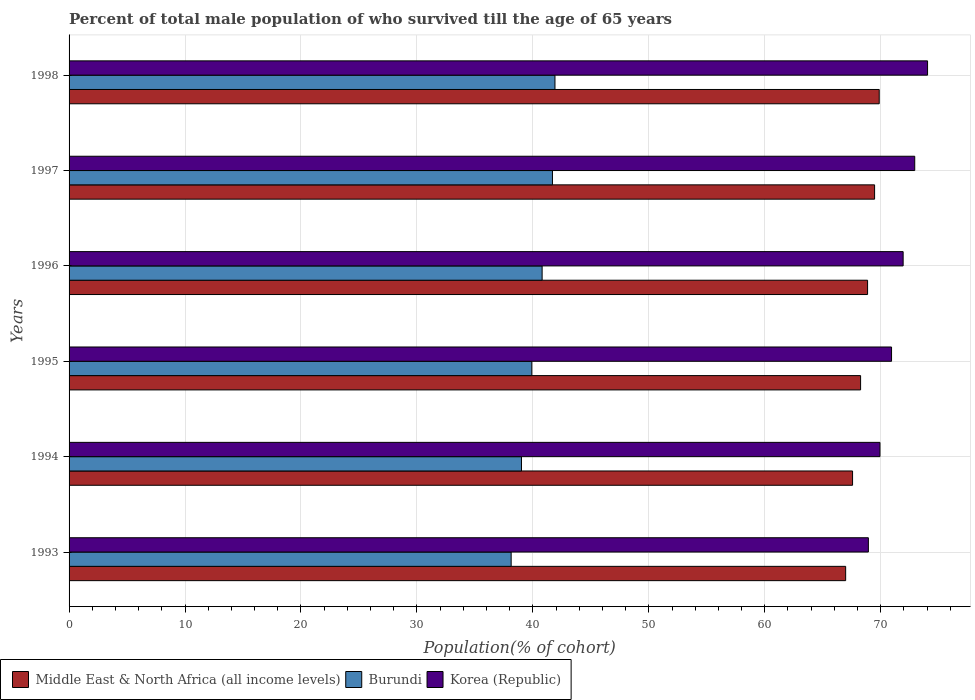How many groups of bars are there?
Offer a very short reply. 6. How many bars are there on the 1st tick from the top?
Ensure brevity in your answer.  3. What is the label of the 5th group of bars from the top?
Make the answer very short. 1994. In how many cases, is the number of bars for a given year not equal to the number of legend labels?
Make the answer very short. 0. What is the percentage of total male population who survived till the age of 65 years in Korea (Republic) in 1993?
Offer a very short reply. 68.94. Across all years, what is the maximum percentage of total male population who survived till the age of 65 years in Middle East & North Africa (all income levels)?
Provide a short and direct response. 69.87. Across all years, what is the minimum percentage of total male population who survived till the age of 65 years in Middle East & North Africa (all income levels)?
Give a very brief answer. 66.98. In which year was the percentage of total male population who survived till the age of 65 years in Middle East & North Africa (all income levels) maximum?
Your response must be concise. 1998. What is the total percentage of total male population who survived till the age of 65 years in Middle East & North Africa (all income levels) in the graph?
Your response must be concise. 411.03. What is the difference between the percentage of total male population who survived till the age of 65 years in Korea (Republic) in 1993 and that in 1998?
Offer a terse response. -5.11. What is the difference between the percentage of total male population who survived till the age of 65 years in Burundi in 1993 and the percentage of total male population who survived till the age of 65 years in Korea (Republic) in 1996?
Your response must be concise. -33.81. What is the average percentage of total male population who survived till the age of 65 years in Korea (Republic) per year?
Offer a terse response. 71.45. In the year 1996, what is the difference between the percentage of total male population who survived till the age of 65 years in Korea (Republic) and percentage of total male population who survived till the age of 65 years in Middle East & North Africa (all income levels)?
Your response must be concise. 3.07. In how many years, is the percentage of total male population who survived till the age of 65 years in Burundi greater than 48 %?
Make the answer very short. 0. What is the ratio of the percentage of total male population who survived till the age of 65 years in Middle East & North Africa (all income levels) in 1996 to that in 1997?
Provide a succinct answer. 0.99. What is the difference between the highest and the second highest percentage of total male population who survived till the age of 65 years in Burundi?
Your answer should be compact. 0.22. What is the difference between the highest and the lowest percentage of total male population who survived till the age of 65 years in Korea (Republic)?
Your answer should be compact. 5.11. In how many years, is the percentage of total male population who survived till the age of 65 years in Korea (Republic) greater than the average percentage of total male population who survived till the age of 65 years in Korea (Republic) taken over all years?
Provide a succinct answer. 3. What does the 1st bar from the top in 1996 represents?
Ensure brevity in your answer.  Korea (Republic). What does the 3rd bar from the bottom in 1998 represents?
Your answer should be compact. Korea (Republic). Is it the case that in every year, the sum of the percentage of total male population who survived till the age of 65 years in Korea (Republic) and percentage of total male population who survived till the age of 65 years in Middle East & North Africa (all income levels) is greater than the percentage of total male population who survived till the age of 65 years in Burundi?
Your answer should be very brief. Yes. How many bars are there?
Your answer should be very brief. 18. Are all the bars in the graph horizontal?
Your answer should be very brief. Yes. How many years are there in the graph?
Provide a succinct answer. 6. Does the graph contain any zero values?
Your answer should be very brief. No. What is the title of the graph?
Offer a very short reply. Percent of total male population of who survived till the age of 65 years. Does "Korea (Democratic)" appear as one of the legend labels in the graph?
Your answer should be compact. No. What is the label or title of the X-axis?
Your response must be concise. Population(% of cohort). What is the label or title of the Y-axis?
Provide a short and direct response. Years. What is the Population(% of cohort) of Middle East & North Africa (all income levels) in 1993?
Make the answer very short. 66.98. What is the Population(% of cohort) of Burundi in 1993?
Your answer should be very brief. 38.13. What is the Population(% of cohort) of Korea (Republic) in 1993?
Ensure brevity in your answer.  68.94. What is the Population(% of cohort) in Middle East & North Africa (all income levels) in 1994?
Your answer should be very brief. 67.57. What is the Population(% of cohort) in Burundi in 1994?
Offer a terse response. 39.02. What is the Population(% of cohort) of Korea (Republic) in 1994?
Ensure brevity in your answer.  69.94. What is the Population(% of cohort) of Middle East & North Africa (all income levels) in 1995?
Ensure brevity in your answer.  68.27. What is the Population(% of cohort) in Burundi in 1995?
Give a very brief answer. 39.91. What is the Population(% of cohort) in Korea (Republic) in 1995?
Ensure brevity in your answer.  70.94. What is the Population(% of cohort) of Middle East & North Africa (all income levels) in 1996?
Give a very brief answer. 68.87. What is the Population(% of cohort) of Burundi in 1996?
Your answer should be very brief. 40.8. What is the Population(% of cohort) in Korea (Republic) in 1996?
Offer a terse response. 71.94. What is the Population(% of cohort) of Middle East & North Africa (all income levels) in 1997?
Provide a succinct answer. 69.47. What is the Population(% of cohort) in Burundi in 1997?
Ensure brevity in your answer.  41.69. What is the Population(% of cohort) of Korea (Republic) in 1997?
Provide a succinct answer. 72.94. What is the Population(% of cohort) in Middle East & North Africa (all income levels) in 1998?
Provide a succinct answer. 69.87. What is the Population(% of cohort) in Burundi in 1998?
Keep it short and to the point. 41.91. What is the Population(% of cohort) of Korea (Republic) in 1998?
Keep it short and to the point. 74.04. Across all years, what is the maximum Population(% of cohort) in Middle East & North Africa (all income levels)?
Give a very brief answer. 69.87. Across all years, what is the maximum Population(% of cohort) of Burundi?
Your answer should be compact. 41.91. Across all years, what is the maximum Population(% of cohort) of Korea (Republic)?
Ensure brevity in your answer.  74.04. Across all years, what is the minimum Population(% of cohort) of Middle East & North Africa (all income levels)?
Provide a succinct answer. 66.98. Across all years, what is the minimum Population(% of cohort) in Burundi?
Provide a short and direct response. 38.13. Across all years, what is the minimum Population(% of cohort) of Korea (Republic)?
Keep it short and to the point. 68.94. What is the total Population(% of cohort) in Middle East & North Africa (all income levels) in the graph?
Your answer should be very brief. 411.03. What is the total Population(% of cohort) in Burundi in the graph?
Ensure brevity in your answer.  241.45. What is the total Population(% of cohort) in Korea (Republic) in the graph?
Make the answer very short. 428.72. What is the difference between the Population(% of cohort) in Middle East & North Africa (all income levels) in 1993 and that in 1994?
Your answer should be compact. -0.6. What is the difference between the Population(% of cohort) of Burundi in 1993 and that in 1994?
Make the answer very short. -0.89. What is the difference between the Population(% of cohort) in Korea (Republic) in 1993 and that in 1994?
Provide a succinct answer. -1. What is the difference between the Population(% of cohort) in Middle East & North Africa (all income levels) in 1993 and that in 1995?
Offer a terse response. -1.29. What is the difference between the Population(% of cohort) in Burundi in 1993 and that in 1995?
Make the answer very short. -1.78. What is the difference between the Population(% of cohort) in Korea (Republic) in 1993 and that in 1995?
Make the answer very short. -2. What is the difference between the Population(% of cohort) in Middle East & North Africa (all income levels) in 1993 and that in 1996?
Your response must be concise. -1.89. What is the difference between the Population(% of cohort) of Burundi in 1993 and that in 1996?
Your response must be concise. -2.67. What is the difference between the Population(% of cohort) of Korea (Republic) in 1993 and that in 1996?
Ensure brevity in your answer.  -3. What is the difference between the Population(% of cohort) of Middle East & North Africa (all income levels) in 1993 and that in 1997?
Provide a short and direct response. -2.5. What is the difference between the Population(% of cohort) in Burundi in 1993 and that in 1997?
Make the answer very short. -3.56. What is the difference between the Population(% of cohort) in Korea (Republic) in 1993 and that in 1997?
Your answer should be very brief. -4. What is the difference between the Population(% of cohort) in Middle East & North Africa (all income levels) in 1993 and that in 1998?
Give a very brief answer. -2.89. What is the difference between the Population(% of cohort) of Burundi in 1993 and that in 1998?
Your response must be concise. -3.78. What is the difference between the Population(% of cohort) in Korea (Republic) in 1993 and that in 1998?
Make the answer very short. -5.11. What is the difference between the Population(% of cohort) in Middle East & North Africa (all income levels) in 1994 and that in 1995?
Offer a terse response. -0.69. What is the difference between the Population(% of cohort) in Burundi in 1994 and that in 1995?
Your response must be concise. -0.89. What is the difference between the Population(% of cohort) in Korea (Republic) in 1994 and that in 1995?
Offer a terse response. -1. What is the difference between the Population(% of cohort) of Middle East & North Africa (all income levels) in 1994 and that in 1996?
Provide a succinct answer. -1.29. What is the difference between the Population(% of cohort) of Burundi in 1994 and that in 1996?
Offer a very short reply. -1.78. What is the difference between the Population(% of cohort) of Korea (Republic) in 1994 and that in 1996?
Make the answer very short. -2. What is the difference between the Population(% of cohort) of Middle East & North Africa (all income levels) in 1994 and that in 1997?
Provide a short and direct response. -1.9. What is the difference between the Population(% of cohort) of Burundi in 1994 and that in 1997?
Provide a short and direct response. -2.67. What is the difference between the Population(% of cohort) in Korea (Republic) in 1994 and that in 1997?
Give a very brief answer. -3. What is the difference between the Population(% of cohort) in Middle East & North Africa (all income levels) in 1994 and that in 1998?
Offer a very short reply. -2.3. What is the difference between the Population(% of cohort) in Burundi in 1994 and that in 1998?
Your answer should be compact. -2.89. What is the difference between the Population(% of cohort) of Korea (Republic) in 1994 and that in 1998?
Provide a short and direct response. -4.11. What is the difference between the Population(% of cohort) in Middle East & North Africa (all income levels) in 1995 and that in 1996?
Ensure brevity in your answer.  -0.6. What is the difference between the Population(% of cohort) in Burundi in 1995 and that in 1996?
Ensure brevity in your answer.  -0.89. What is the difference between the Population(% of cohort) in Korea (Republic) in 1995 and that in 1996?
Your answer should be very brief. -1. What is the difference between the Population(% of cohort) of Middle East & North Africa (all income levels) in 1995 and that in 1997?
Ensure brevity in your answer.  -1.21. What is the difference between the Population(% of cohort) of Burundi in 1995 and that in 1997?
Provide a short and direct response. -1.78. What is the difference between the Population(% of cohort) in Korea (Republic) in 1995 and that in 1997?
Ensure brevity in your answer.  -2. What is the difference between the Population(% of cohort) in Middle East & North Africa (all income levels) in 1995 and that in 1998?
Your response must be concise. -1.61. What is the difference between the Population(% of cohort) in Burundi in 1995 and that in 1998?
Provide a short and direct response. -2. What is the difference between the Population(% of cohort) of Korea (Republic) in 1995 and that in 1998?
Offer a very short reply. -3.11. What is the difference between the Population(% of cohort) of Middle East & North Africa (all income levels) in 1996 and that in 1997?
Provide a succinct answer. -0.61. What is the difference between the Population(% of cohort) in Burundi in 1996 and that in 1997?
Ensure brevity in your answer.  -0.89. What is the difference between the Population(% of cohort) of Korea (Republic) in 1996 and that in 1997?
Offer a terse response. -1. What is the difference between the Population(% of cohort) of Middle East & North Africa (all income levels) in 1996 and that in 1998?
Offer a very short reply. -1. What is the difference between the Population(% of cohort) in Burundi in 1996 and that in 1998?
Make the answer very short. -1.11. What is the difference between the Population(% of cohort) of Korea (Republic) in 1996 and that in 1998?
Keep it short and to the point. -2.11. What is the difference between the Population(% of cohort) of Middle East & North Africa (all income levels) in 1997 and that in 1998?
Make the answer very short. -0.4. What is the difference between the Population(% of cohort) in Burundi in 1997 and that in 1998?
Ensure brevity in your answer.  -0.22. What is the difference between the Population(% of cohort) in Korea (Republic) in 1997 and that in 1998?
Your answer should be very brief. -1.11. What is the difference between the Population(% of cohort) of Middle East & North Africa (all income levels) in 1993 and the Population(% of cohort) of Burundi in 1994?
Offer a terse response. 27.96. What is the difference between the Population(% of cohort) in Middle East & North Africa (all income levels) in 1993 and the Population(% of cohort) in Korea (Republic) in 1994?
Provide a short and direct response. -2.96. What is the difference between the Population(% of cohort) in Burundi in 1993 and the Population(% of cohort) in Korea (Republic) in 1994?
Offer a very short reply. -31.81. What is the difference between the Population(% of cohort) in Middle East & North Africa (all income levels) in 1993 and the Population(% of cohort) in Burundi in 1995?
Your response must be concise. 27.07. What is the difference between the Population(% of cohort) of Middle East & North Africa (all income levels) in 1993 and the Population(% of cohort) of Korea (Republic) in 1995?
Provide a short and direct response. -3.96. What is the difference between the Population(% of cohort) of Burundi in 1993 and the Population(% of cohort) of Korea (Republic) in 1995?
Your response must be concise. -32.81. What is the difference between the Population(% of cohort) of Middle East & North Africa (all income levels) in 1993 and the Population(% of cohort) of Burundi in 1996?
Keep it short and to the point. 26.18. What is the difference between the Population(% of cohort) in Middle East & North Africa (all income levels) in 1993 and the Population(% of cohort) in Korea (Republic) in 1996?
Your response must be concise. -4.96. What is the difference between the Population(% of cohort) in Burundi in 1993 and the Population(% of cohort) in Korea (Republic) in 1996?
Your answer should be very brief. -33.81. What is the difference between the Population(% of cohort) in Middle East & North Africa (all income levels) in 1993 and the Population(% of cohort) in Burundi in 1997?
Give a very brief answer. 25.29. What is the difference between the Population(% of cohort) in Middle East & North Africa (all income levels) in 1993 and the Population(% of cohort) in Korea (Republic) in 1997?
Offer a terse response. -5.96. What is the difference between the Population(% of cohort) of Burundi in 1993 and the Population(% of cohort) of Korea (Republic) in 1997?
Offer a very short reply. -34.81. What is the difference between the Population(% of cohort) in Middle East & North Africa (all income levels) in 1993 and the Population(% of cohort) in Burundi in 1998?
Give a very brief answer. 25.07. What is the difference between the Population(% of cohort) in Middle East & North Africa (all income levels) in 1993 and the Population(% of cohort) in Korea (Republic) in 1998?
Offer a very short reply. -7.06. What is the difference between the Population(% of cohort) of Burundi in 1993 and the Population(% of cohort) of Korea (Republic) in 1998?
Give a very brief answer. -35.91. What is the difference between the Population(% of cohort) in Middle East & North Africa (all income levels) in 1994 and the Population(% of cohort) in Burundi in 1995?
Provide a short and direct response. 27.66. What is the difference between the Population(% of cohort) of Middle East & North Africa (all income levels) in 1994 and the Population(% of cohort) of Korea (Republic) in 1995?
Give a very brief answer. -3.36. What is the difference between the Population(% of cohort) of Burundi in 1994 and the Population(% of cohort) of Korea (Republic) in 1995?
Provide a short and direct response. -31.92. What is the difference between the Population(% of cohort) in Middle East & North Africa (all income levels) in 1994 and the Population(% of cohort) in Burundi in 1996?
Offer a very short reply. 26.77. What is the difference between the Population(% of cohort) of Middle East & North Africa (all income levels) in 1994 and the Population(% of cohort) of Korea (Republic) in 1996?
Keep it short and to the point. -4.36. What is the difference between the Population(% of cohort) of Burundi in 1994 and the Population(% of cohort) of Korea (Republic) in 1996?
Give a very brief answer. -32.92. What is the difference between the Population(% of cohort) in Middle East & North Africa (all income levels) in 1994 and the Population(% of cohort) in Burundi in 1997?
Provide a succinct answer. 25.88. What is the difference between the Population(% of cohort) of Middle East & North Africa (all income levels) in 1994 and the Population(% of cohort) of Korea (Republic) in 1997?
Your answer should be very brief. -5.36. What is the difference between the Population(% of cohort) of Burundi in 1994 and the Population(% of cohort) of Korea (Republic) in 1997?
Offer a terse response. -33.92. What is the difference between the Population(% of cohort) of Middle East & North Africa (all income levels) in 1994 and the Population(% of cohort) of Burundi in 1998?
Keep it short and to the point. 25.67. What is the difference between the Population(% of cohort) in Middle East & North Africa (all income levels) in 1994 and the Population(% of cohort) in Korea (Republic) in 1998?
Offer a very short reply. -6.47. What is the difference between the Population(% of cohort) of Burundi in 1994 and the Population(% of cohort) of Korea (Republic) in 1998?
Your answer should be compact. -35.02. What is the difference between the Population(% of cohort) in Middle East & North Africa (all income levels) in 1995 and the Population(% of cohort) in Burundi in 1996?
Give a very brief answer. 27.47. What is the difference between the Population(% of cohort) of Middle East & North Africa (all income levels) in 1995 and the Population(% of cohort) of Korea (Republic) in 1996?
Offer a terse response. -3.67. What is the difference between the Population(% of cohort) of Burundi in 1995 and the Population(% of cohort) of Korea (Republic) in 1996?
Your answer should be very brief. -32.03. What is the difference between the Population(% of cohort) of Middle East & North Africa (all income levels) in 1995 and the Population(% of cohort) of Burundi in 1997?
Offer a very short reply. 26.58. What is the difference between the Population(% of cohort) of Middle East & North Africa (all income levels) in 1995 and the Population(% of cohort) of Korea (Republic) in 1997?
Offer a very short reply. -4.67. What is the difference between the Population(% of cohort) of Burundi in 1995 and the Population(% of cohort) of Korea (Republic) in 1997?
Offer a very short reply. -33.03. What is the difference between the Population(% of cohort) of Middle East & North Africa (all income levels) in 1995 and the Population(% of cohort) of Burundi in 1998?
Ensure brevity in your answer.  26.36. What is the difference between the Population(% of cohort) of Middle East & North Africa (all income levels) in 1995 and the Population(% of cohort) of Korea (Republic) in 1998?
Your response must be concise. -5.78. What is the difference between the Population(% of cohort) in Burundi in 1995 and the Population(% of cohort) in Korea (Republic) in 1998?
Your answer should be compact. -34.13. What is the difference between the Population(% of cohort) in Middle East & North Africa (all income levels) in 1996 and the Population(% of cohort) in Burundi in 1997?
Make the answer very short. 27.18. What is the difference between the Population(% of cohort) in Middle East & North Africa (all income levels) in 1996 and the Population(% of cohort) in Korea (Republic) in 1997?
Give a very brief answer. -4.07. What is the difference between the Population(% of cohort) in Burundi in 1996 and the Population(% of cohort) in Korea (Republic) in 1997?
Your answer should be compact. -32.14. What is the difference between the Population(% of cohort) of Middle East & North Africa (all income levels) in 1996 and the Population(% of cohort) of Burundi in 1998?
Give a very brief answer. 26.96. What is the difference between the Population(% of cohort) in Middle East & North Africa (all income levels) in 1996 and the Population(% of cohort) in Korea (Republic) in 1998?
Give a very brief answer. -5.17. What is the difference between the Population(% of cohort) of Burundi in 1996 and the Population(% of cohort) of Korea (Republic) in 1998?
Provide a short and direct response. -33.24. What is the difference between the Population(% of cohort) of Middle East & North Africa (all income levels) in 1997 and the Population(% of cohort) of Burundi in 1998?
Your answer should be very brief. 27.57. What is the difference between the Population(% of cohort) of Middle East & North Africa (all income levels) in 1997 and the Population(% of cohort) of Korea (Republic) in 1998?
Keep it short and to the point. -4.57. What is the difference between the Population(% of cohort) of Burundi in 1997 and the Population(% of cohort) of Korea (Republic) in 1998?
Your answer should be very brief. -32.35. What is the average Population(% of cohort) of Middle East & North Africa (all income levels) per year?
Ensure brevity in your answer.  68.51. What is the average Population(% of cohort) in Burundi per year?
Ensure brevity in your answer.  40.24. What is the average Population(% of cohort) in Korea (Republic) per year?
Your response must be concise. 71.45. In the year 1993, what is the difference between the Population(% of cohort) of Middle East & North Africa (all income levels) and Population(% of cohort) of Burundi?
Your answer should be compact. 28.85. In the year 1993, what is the difference between the Population(% of cohort) in Middle East & North Africa (all income levels) and Population(% of cohort) in Korea (Republic)?
Provide a succinct answer. -1.96. In the year 1993, what is the difference between the Population(% of cohort) of Burundi and Population(% of cohort) of Korea (Republic)?
Give a very brief answer. -30.81. In the year 1994, what is the difference between the Population(% of cohort) of Middle East & North Africa (all income levels) and Population(% of cohort) of Burundi?
Offer a terse response. 28.55. In the year 1994, what is the difference between the Population(% of cohort) of Middle East & North Africa (all income levels) and Population(% of cohort) of Korea (Republic)?
Give a very brief answer. -2.36. In the year 1994, what is the difference between the Population(% of cohort) of Burundi and Population(% of cohort) of Korea (Republic)?
Offer a very short reply. -30.92. In the year 1995, what is the difference between the Population(% of cohort) of Middle East & North Africa (all income levels) and Population(% of cohort) of Burundi?
Your response must be concise. 28.36. In the year 1995, what is the difference between the Population(% of cohort) of Middle East & North Africa (all income levels) and Population(% of cohort) of Korea (Republic)?
Your answer should be very brief. -2.67. In the year 1995, what is the difference between the Population(% of cohort) in Burundi and Population(% of cohort) in Korea (Republic)?
Your response must be concise. -31.03. In the year 1996, what is the difference between the Population(% of cohort) of Middle East & North Africa (all income levels) and Population(% of cohort) of Burundi?
Ensure brevity in your answer.  28.07. In the year 1996, what is the difference between the Population(% of cohort) of Middle East & North Africa (all income levels) and Population(% of cohort) of Korea (Republic)?
Your answer should be compact. -3.07. In the year 1996, what is the difference between the Population(% of cohort) of Burundi and Population(% of cohort) of Korea (Republic)?
Make the answer very short. -31.14. In the year 1997, what is the difference between the Population(% of cohort) of Middle East & North Africa (all income levels) and Population(% of cohort) of Burundi?
Give a very brief answer. 27.78. In the year 1997, what is the difference between the Population(% of cohort) of Middle East & North Africa (all income levels) and Population(% of cohort) of Korea (Republic)?
Make the answer very short. -3.46. In the year 1997, what is the difference between the Population(% of cohort) in Burundi and Population(% of cohort) in Korea (Republic)?
Offer a very short reply. -31.25. In the year 1998, what is the difference between the Population(% of cohort) of Middle East & North Africa (all income levels) and Population(% of cohort) of Burundi?
Your answer should be very brief. 27.96. In the year 1998, what is the difference between the Population(% of cohort) of Middle East & North Africa (all income levels) and Population(% of cohort) of Korea (Republic)?
Provide a succinct answer. -4.17. In the year 1998, what is the difference between the Population(% of cohort) of Burundi and Population(% of cohort) of Korea (Republic)?
Your response must be concise. -32.13. What is the ratio of the Population(% of cohort) of Burundi in 1993 to that in 1994?
Offer a very short reply. 0.98. What is the ratio of the Population(% of cohort) in Korea (Republic) in 1993 to that in 1994?
Make the answer very short. 0.99. What is the ratio of the Population(% of cohort) in Middle East & North Africa (all income levels) in 1993 to that in 1995?
Your response must be concise. 0.98. What is the ratio of the Population(% of cohort) of Burundi in 1993 to that in 1995?
Offer a very short reply. 0.96. What is the ratio of the Population(% of cohort) in Korea (Republic) in 1993 to that in 1995?
Your answer should be compact. 0.97. What is the ratio of the Population(% of cohort) in Middle East & North Africa (all income levels) in 1993 to that in 1996?
Offer a very short reply. 0.97. What is the ratio of the Population(% of cohort) of Burundi in 1993 to that in 1996?
Provide a short and direct response. 0.93. What is the ratio of the Population(% of cohort) of Korea (Republic) in 1993 to that in 1996?
Keep it short and to the point. 0.96. What is the ratio of the Population(% of cohort) in Middle East & North Africa (all income levels) in 1993 to that in 1997?
Keep it short and to the point. 0.96. What is the ratio of the Population(% of cohort) in Burundi in 1993 to that in 1997?
Your response must be concise. 0.91. What is the ratio of the Population(% of cohort) of Korea (Republic) in 1993 to that in 1997?
Your answer should be very brief. 0.95. What is the ratio of the Population(% of cohort) of Middle East & North Africa (all income levels) in 1993 to that in 1998?
Your response must be concise. 0.96. What is the ratio of the Population(% of cohort) of Burundi in 1993 to that in 1998?
Offer a terse response. 0.91. What is the ratio of the Population(% of cohort) of Middle East & North Africa (all income levels) in 1994 to that in 1995?
Ensure brevity in your answer.  0.99. What is the ratio of the Population(% of cohort) in Burundi in 1994 to that in 1995?
Your answer should be very brief. 0.98. What is the ratio of the Population(% of cohort) of Korea (Republic) in 1994 to that in 1995?
Give a very brief answer. 0.99. What is the ratio of the Population(% of cohort) of Middle East & North Africa (all income levels) in 1994 to that in 1996?
Your answer should be very brief. 0.98. What is the ratio of the Population(% of cohort) of Burundi in 1994 to that in 1996?
Offer a very short reply. 0.96. What is the ratio of the Population(% of cohort) of Korea (Republic) in 1994 to that in 1996?
Offer a very short reply. 0.97. What is the ratio of the Population(% of cohort) of Middle East & North Africa (all income levels) in 1994 to that in 1997?
Your response must be concise. 0.97. What is the ratio of the Population(% of cohort) of Burundi in 1994 to that in 1997?
Your answer should be very brief. 0.94. What is the ratio of the Population(% of cohort) of Korea (Republic) in 1994 to that in 1997?
Provide a short and direct response. 0.96. What is the ratio of the Population(% of cohort) of Middle East & North Africa (all income levels) in 1994 to that in 1998?
Make the answer very short. 0.97. What is the ratio of the Population(% of cohort) of Burundi in 1994 to that in 1998?
Your answer should be very brief. 0.93. What is the ratio of the Population(% of cohort) of Korea (Republic) in 1994 to that in 1998?
Make the answer very short. 0.94. What is the ratio of the Population(% of cohort) in Burundi in 1995 to that in 1996?
Give a very brief answer. 0.98. What is the ratio of the Population(% of cohort) of Korea (Republic) in 1995 to that in 1996?
Your answer should be very brief. 0.99. What is the ratio of the Population(% of cohort) in Middle East & North Africa (all income levels) in 1995 to that in 1997?
Give a very brief answer. 0.98. What is the ratio of the Population(% of cohort) of Burundi in 1995 to that in 1997?
Your response must be concise. 0.96. What is the ratio of the Population(% of cohort) in Korea (Republic) in 1995 to that in 1997?
Provide a short and direct response. 0.97. What is the ratio of the Population(% of cohort) in Burundi in 1995 to that in 1998?
Your response must be concise. 0.95. What is the ratio of the Population(% of cohort) in Korea (Republic) in 1995 to that in 1998?
Your answer should be very brief. 0.96. What is the ratio of the Population(% of cohort) of Burundi in 1996 to that in 1997?
Provide a succinct answer. 0.98. What is the ratio of the Population(% of cohort) in Korea (Republic) in 1996 to that in 1997?
Offer a very short reply. 0.99. What is the ratio of the Population(% of cohort) in Middle East & North Africa (all income levels) in 1996 to that in 1998?
Provide a succinct answer. 0.99. What is the ratio of the Population(% of cohort) of Burundi in 1996 to that in 1998?
Ensure brevity in your answer.  0.97. What is the ratio of the Population(% of cohort) in Korea (Republic) in 1996 to that in 1998?
Keep it short and to the point. 0.97. What is the ratio of the Population(% of cohort) of Burundi in 1997 to that in 1998?
Offer a terse response. 0.99. What is the ratio of the Population(% of cohort) of Korea (Republic) in 1997 to that in 1998?
Keep it short and to the point. 0.99. What is the difference between the highest and the second highest Population(% of cohort) of Middle East & North Africa (all income levels)?
Offer a terse response. 0.4. What is the difference between the highest and the second highest Population(% of cohort) in Burundi?
Provide a short and direct response. 0.22. What is the difference between the highest and the second highest Population(% of cohort) of Korea (Republic)?
Provide a succinct answer. 1.11. What is the difference between the highest and the lowest Population(% of cohort) of Middle East & North Africa (all income levels)?
Your answer should be compact. 2.89. What is the difference between the highest and the lowest Population(% of cohort) of Burundi?
Make the answer very short. 3.78. What is the difference between the highest and the lowest Population(% of cohort) in Korea (Republic)?
Keep it short and to the point. 5.11. 